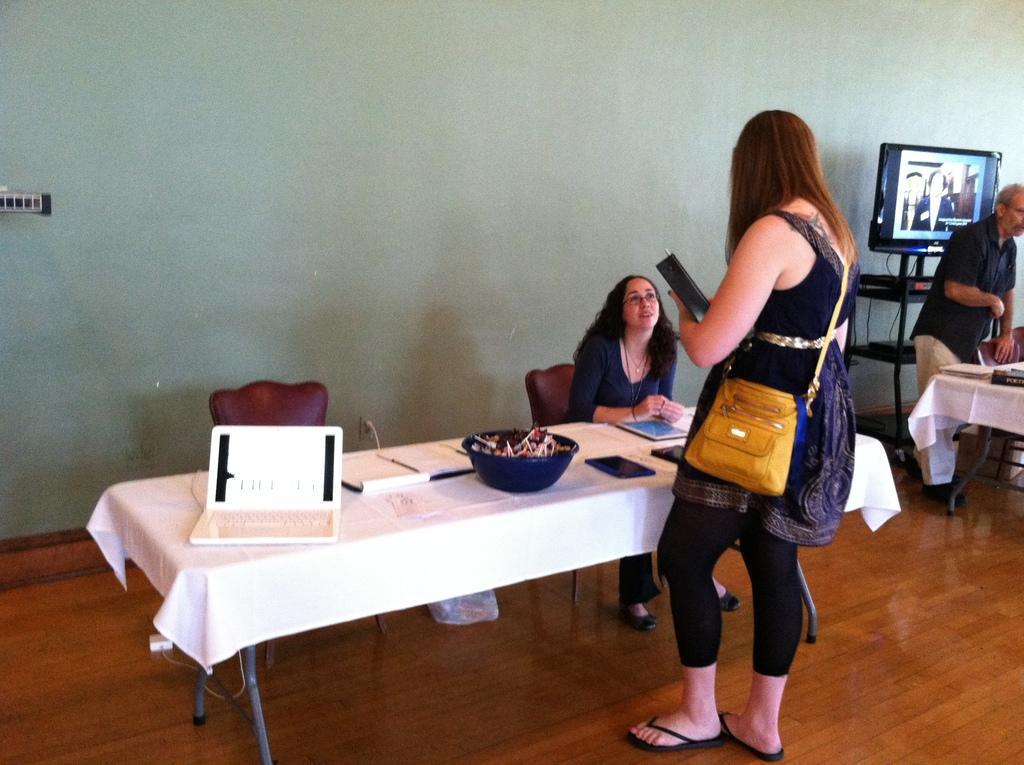Please provide a concise description of this image. In the middle there is a table on that table there is a bowl ,laptop, book ,tablet and some other items ,the table is covered with cloth ,In front of the table there is a woman she wear a hand bag her hair is small ,i think she is speaking with the girl in front of her. On the right there is a man standing ,he wear a black shirt and trouser. In the middle there is a woman sitting and speaking with a woman in front of her. In the background there is a wall and television. 